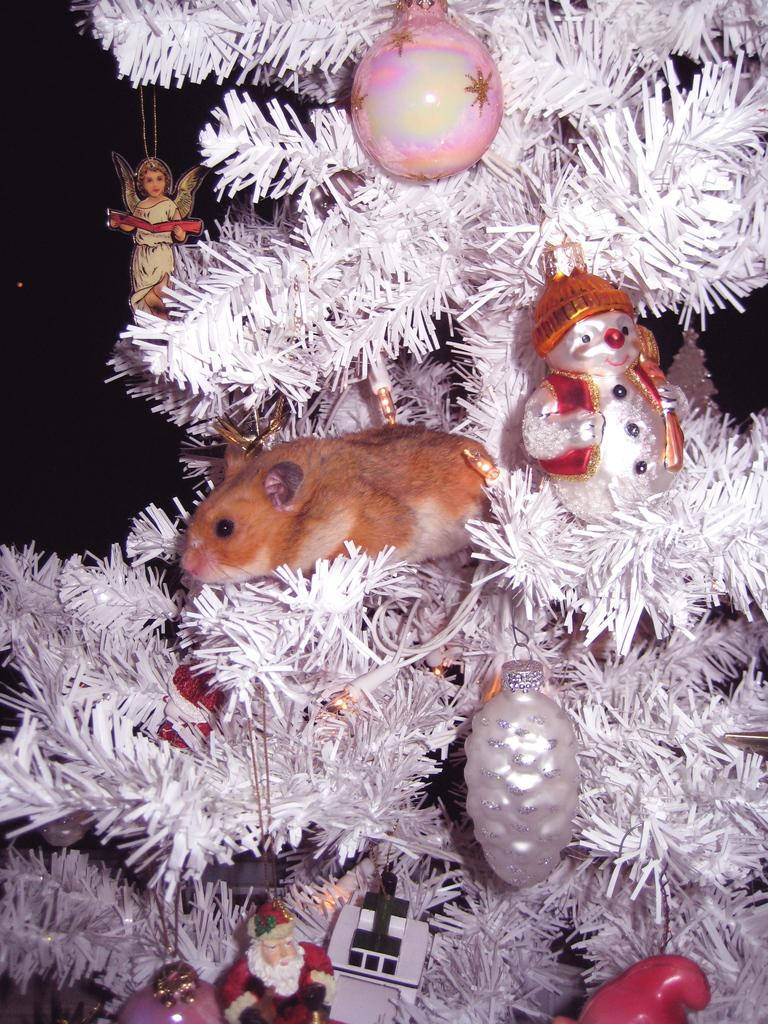What type of tree is featured in the image? There is a Christmas tree in the image. Are there any animals or creatures present on the Christmas tree? Yes, a rat is present on the Christmas tree. What type of tooth can be seen in the image? There is no tooth present in the image; it features a Christmas tree with a rat on it. 